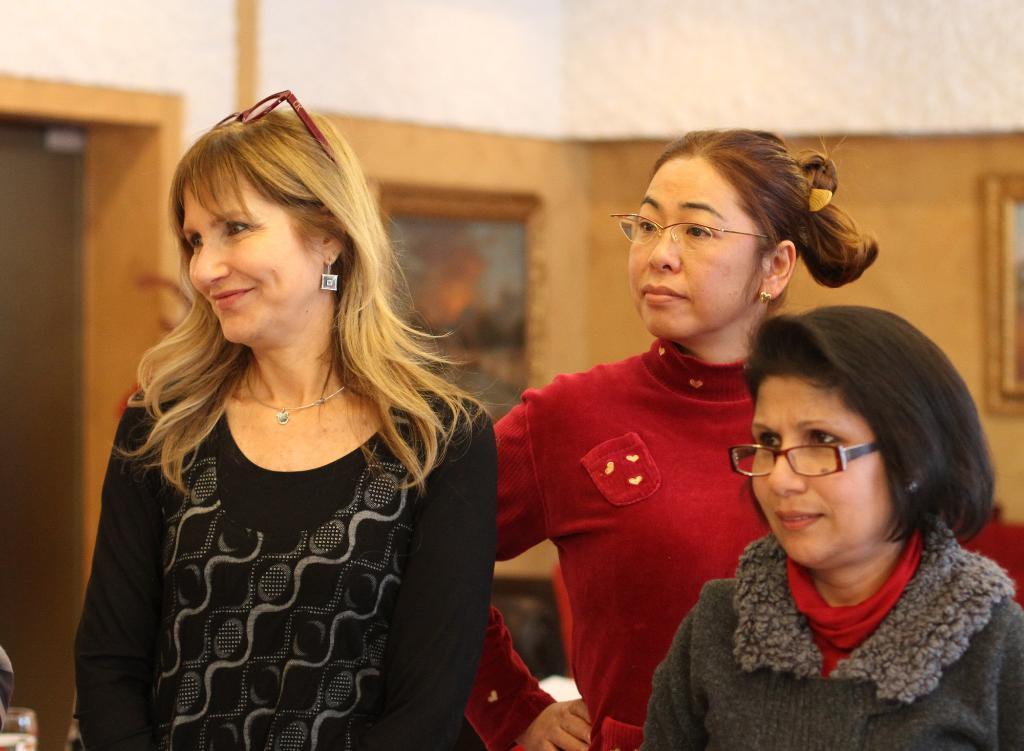How would you summarize this image in a sentence or two? In this picture we can see three women. We can see a woman wearing a black top is smiling on the left side. There is a glass visible in the bottom left. We can see a few frames on the wall. Background is blurry. 